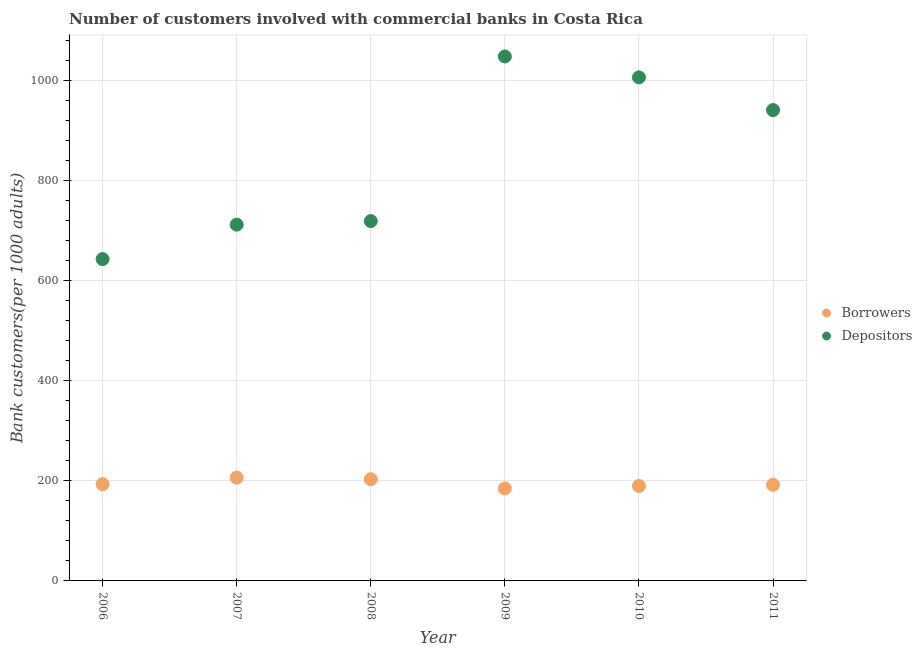How many different coloured dotlines are there?
Your response must be concise. 2. Is the number of dotlines equal to the number of legend labels?
Give a very brief answer. Yes. What is the number of borrowers in 2011?
Make the answer very short. 191.98. Across all years, what is the maximum number of depositors?
Make the answer very short. 1047.71. Across all years, what is the minimum number of depositors?
Your answer should be very brief. 642.93. What is the total number of borrowers in the graph?
Ensure brevity in your answer.  1169.06. What is the difference between the number of depositors in 2008 and that in 2011?
Ensure brevity in your answer.  -221.76. What is the difference between the number of depositors in 2011 and the number of borrowers in 2008?
Ensure brevity in your answer.  737.53. What is the average number of depositors per year?
Make the answer very short. 844.62. In the year 2007, what is the difference between the number of depositors and number of borrowers?
Make the answer very short. 505.35. What is the ratio of the number of depositors in 2006 to that in 2011?
Provide a succinct answer. 0.68. Is the number of depositors in 2007 less than that in 2009?
Keep it short and to the point. Yes. Is the difference between the number of borrowers in 2006 and 2011 greater than the difference between the number of depositors in 2006 and 2011?
Your response must be concise. Yes. What is the difference between the highest and the second highest number of borrowers?
Ensure brevity in your answer.  3.24. What is the difference between the highest and the lowest number of depositors?
Your response must be concise. 404.79. Is the sum of the number of depositors in 2006 and 2010 greater than the maximum number of borrowers across all years?
Your answer should be compact. Yes. Does the number of depositors monotonically increase over the years?
Provide a short and direct response. No. Is the number of depositors strictly greater than the number of borrowers over the years?
Give a very brief answer. Yes. How many years are there in the graph?
Your answer should be compact. 6. What is the difference between two consecutive major ticks on the Y-axis?
Make the answer very short. 200. Are the values on the major ticks of Y-axis written in scientific E-notation?
Offer a very short reply. No. Does the graph contain grids?
Your answer should be very brief. Yes. Where does the legend appear in the graph?
Your answer should be compact. Center right. How are the legend labels stacked?
Offer a terse response. Vertical. What is the title of the graph?
Offer a terse response. Number of customers involved with commercial banks in Costa Rica. What is the label or title of the X-axis?
Make the answer very short. Year. What is the label or title of the Y-axis?
Offer a terse response. Bank customers(per 1000 adults). What is the Bank customers(per 1000 adults) of Borrowers in 2006?
Your answer should be very brief. 193.3. What is the Bank customers(per 1000 adults) in Depositors in 2006?
Ensure brevity in your answer.  642.93. What is the Bank customers(per 1000 adults) in Borrowers in 2007?
Your answer should be compact. 206.33. What is the Bank customers(per 1000 adults) of Depositors in 2007?
Provide a succinct answer. 711.68. What is the Bank customers(per 1000 adults) in Borrowers in 2008?
Keep it short and to the point. 203.09. What is the Bank customers(per 1000 adults) of Depositors in 2008?
Your answer should be very brief. 718.87. What is the Bank customers(per 1000 adults) in Borrowers in 2009?
Your answer should be very brief. 184.73. What is the Bank customers(per 1000 adults) of Depositors in 2009?
Provide a short and direct response. 1047.71. What is the Bank customers(per 1000 adults) in Borrowers in 2010?
Your response must be concise. 189.63. What is the Bank customers(per 1000 adults) in Depositors in 2010?
Provide a succinct answer. 1005.94. What is the Bank customers(per 1000 adults) of Borrowers in 2011?
Ensure brevity in your answer.  191.98. What is the Bank customers(per 1000 adults) of Depositors in 2011?
Provide a short and direct response. 940.62. Across all years, what is the maximum Bank customers(per 1000 adults) of Borrowers?
Keep it short and to the point. 206.33. Across all years, what is the maximum Bank customers(per 1000 adults) in Depositors?
Provide a succinct answer. 1047.71. Across all years, what is the minimum Bank customers(per 1000 adults) in Borrowers?
Give a very brief answer. 184.73. Across all years, what is the minimum Bank customers(per 1000 adults) of Depositors?
Keep it short and to the point. 642.93. What is the total Bank customers(per 1000 adults) of Borrowers in the graph?
Provide a succinct answer. 1169.06. What is the total Bank customers(per 1000 adults) of Depositors in the graph?
Offer a terse response. 5067.75. What is the difference between the Bank customers(per 1000 adults) of Borrowers in 2006 and that in 2007?
Provide a succinct answer. -13.03. What is the difference between the Bank customers(per 1000 adults) of Depositors in 2006 and that in 2007?
Your response must be concise. -68.75. What is the difference between the Bank customers(per 1000 adults) in Borrowers in 2006 and that in 2008?
Provide a short and direct response. -9.79. What is the difference between the Bank customers(per 1000 adults) of Depositors in 2006 and that in 2008?
Provide a short and direct response. -75.94. What is the difference between the Bank customers(per 1000 adults) of Borrowers in 2006 and that in 2009?
Provide a short and direct response. 8.58. What is the difference between the Bank customers(per 1000 adults) in Depositors in 2006 and that in 2009?
Offer a very short reply. -404.79. What is the difference between the Bank customers(per 1000 adults) of Borrowers in 2006 and that in 2010?
Provide a succinct answer. 3.68. What is the difference between the Bank customers(per 1000 adults) in Depositors in 2006 and that in 2010?
Provide a succinct answer. -363.02. What is the difference between the Bank customers(per 1000 adults) in Borrowers in 2006 and that in 2011?
Your answer should be very brief. 1.32. What is the difference between the Bank customers(per 1000 adults) of Depositors in 2006 and that in 2011?
Ensure brevity in your answer.  -297.7. What is the difference between the Bank customers(per 1000 adults) of Borrowers in 2007 and that in 2008?
Your response must be concise. 3.24. What is the difference between the Bank customers(per 1000 adults) of Depositors in 2007 and that in 2008?
Keep it short and to the point. -7.19. What is the difference between the Bank customers(per 1000 adults) in Borrowers in 2007 and that in 2009?
Ensure brevity in your answer.  21.6. What is the difference between the Bank customers(per 1000 adults) of Depositors in 2007 and that in 2009?
Your response must be concise. -336.04. What is the difference between the Bank customers(per 1000 adults) in Borrowers in 2007 and that in 2010?
Provide a succinct answer. 16.7. What is the difference between the Bank customers(per 1000 adults) in Depositors in 2007 and that in 2010?
Give a very brief answer. -294.27. What is the difference between the Bank customers(per 1000 adults) of Borrowers in 2007 and that in 2011?
Provide a short and direct response. 14.35. What is the difference between the Bank customers(per 1000 adults) in Depositors in 2007 and that in 2011?
Keep it short and to the point. -228.95. What is the difference between the Bank customers(per 1000 adults) in Borrowers in 2008 and that in 2009?
Make the answer very short. 18.36. What is the difference between the Bank customers(per 1000 adults) in Depositors in 2008 and that in 2009?
Provide a succinct answer. -328.85. What is the difference between the Bank customers(per 1000 adults) of Borrowers in 2008 and that in 2010?
Your answer should be very brief. 13.46. What is the difference between the Bank customers(per 1000 adults) in Depositors in 2008 and that in 2010?
Offer a very short reply. -287.08. What is the difference between the Bank customers(per 1000 adults) of Borrowers in 2008 and that in 2011?
Provide a succinct answer. 11.11. What is the difference between the Bank customers(per 1000 adults) in Depositors in 2008 and that in 2011?
Offer a very short reply. -221.76. What is the difference between the Bank customers(per 1000 adults) of Borrowers in 2009 and that in 2010?
Provide a short and direct response. -4.9. What is the difference between the Bank customers(per 1000 adults) in Depositors in 2009 and that in 2010?
Make the answer very short. 41.77. What is the difference between the Bank customers(per 1000 adults) in Borrowers in 2009 and that in 2011?
Your answer should be compact. -7.25. What is the difference between the Bank customers(per 1000 adults) in Depositors in 2009 and that in 2011?
Provide a succinct answer. 107.09. What is the difference between the Bank customers(per 1000 adults) of Borrowers in 2010 and that in 2011?
Give a very brief answer. -2.35. What is the difference between the Bank customers(per 1000 adults) in Depositors in 2010 and that in 2011?
Your answer should be very brief. 65.32. What is the difference between the Bank customers(per 1000 adults) in Borrowers in 2006 and the Bank customers(per 1000 adults) in Depositors in 2007?
Ensure brevity in your answer.  -518.37. What is the difference between the Bank customers(per 1000 adults) in Borrowers in 2006 and the Bank customers(per 1000 adults) in Depositors in 2008?
Give a very brief answer. -525.56. What is the difference between the Bank customers(per 1000 adults) of Borrowers in 2006 and the Bank customers(per 1000 adults) of Depositors in 2009?
Ensure brevity in your answer.  -854.41. What is the difference between the Bank customers(per 1000 adults) in Borrowers in 2006 and the Bank customers(per 1000 adults) in Depositors in 2010?
Offer a very short reply. -812.64. What is the difference between the Bank customers(per 1000 adults) of Borrowers in 2006 and the Bank customers(per 1000 adults) of Depositors in 2011?
Offer a terse response. -747.32. What is the difference between the Bank customers(per 1000 adults) of Borrowers in 2007 and the Bank customers(per 1000 adults) of Depositors in 2008?
Keep it short and to the point. -512.54. What is the difference between the Bank customers(per 1000 adults) of Borrowers in 2007 and the Bank customers(per 1000 adults) of Depositors in 2009?
Your response must be concise. -841.38. What is the difference between the Bank customers(per 1000 adults) in Borrowers in 2007 and the Bank customers(per 1000 adults) in Depositors in 2010?
Provide a succinct answer. -799.61. What is the difference between the Bank customers(per 1000 adults) in Borrowers in 2007 and the Bank customers(per 1000 adults) in Depositors in 2011?
Offer a terse response. -734.29. What is the difference between the Bank customers(per 1000 adults) of Borrowers in 2008 and the Bank customers(per 1000 adults) of Depositors in 2009?
Give a very brief answer. -844.62. What is the difference between the Bank customers(per 1000 adults) in Borrowers in 2008 and the Bank customers(per 1000 adults) in Depositors in 2010?
Provide a short and direct response. -802.85. What is the difference between the Bank customers(per 1000 adults) of Borrowers in 2008 and the Bank customers(per 1000 adults) of Depositors in 2011?
Your answer should be very brief. -737.53. What is the difference between the Bank customers(per 1000 adults) of Borrowers in 2009 and the Bank customers(per 1000 adults) of Depositors in 2010?
Offer a terse response. -821.21. What is the difference between the Bank customers(per 1000 adults) of Borrowers in 2009 and the Bank customers(per 1000 adults) of Depositors in 2011?
Provide a succinct answer. -755.89. What is the difference between the Bank customers(per 1000 adults) in Borrowers in 2010 and the Bank customers(per 1000 adults) in Depositors in 2011?
Your answer should be compact. -750.99. What is the average Bank customers(per 1000 adults) in Borrowers per year?
Your response must be concise. 194.84. What is the average Bank customers(per 1000 adults) of Depositors per year?
Offer a very short reply. 844.62. In the year 2006, what is the difference between the Bank customers(per 1000 adults) of Borrowers and Bank customers(per 1000 adults) of Depositors?
Your answer should be very brief. -449.62. In the year 2007, what is the difference between the Bank customers(per 1000 adults) in Borrowers and Bank customers(per 1000 adults) in Depositors?
Give a very brief answer. -505.35. In the year 2008, what is the difference between the Bank customers(per 1000 adults) in Borrowers and Bank customers(per 1000 adults) in Depositors?
Keep it short and to the point. -515.78. In the year 2009, what is the difference between the Bank customers(per 1000 adults) of Borrowers and Bank customers(per 1000 adults) of Depositors?
Your answer should be compact. -862.99. In the year 2010, what is the difference between the Bank customers(per 1000 adults) of Borrowers and Bank customers(per 1000 adults) of Depositors?
Offer a very short reply. -816.31. In the year 2011, what is the difference between the Bank customers(per 1000 adults) in Borrowers and Bank customers(per 1000 adults) in Depositors?
Provide a short and direct response. -748.64. What is the ratio of the Bank customers(per 1000 adults) of Borrowers in 2006 to that in 2007?
Provide a short and direct response. 0.94. What is the ratio of the Bank customers(per 1000 adults) in Depositors in 2006 to that in 2007?
Your answer should be very brief. 0.9. What is the ratio of the Bank customers(per 1000 adults) of Borrowers in 2006 to that in 2008?
Your answer should be compact. 0.95. What is the ratio of the Bank customers(per 1000 adults) in Depositors in 2006 to that in 2008?
Make the answer very short. 0.89. What is the ratio of the Bank customers(per 1000 adults) in Borrowers in 2006 to that in 2009?
Provide a short and direct response. 1.05. What is the ratio of the Bank customers(per 1000 adults) in Depositors in 2006 to that in 2009?
Make the answer very short. 0.61. What is the ratio of the Bank customers(per 1000 adults) of Borrowers in 2006 to that in 2010?
Offer a terse response. 1.02. What is the ratio of the Bank customers(per 1000 adults) in Depositors in 2006 to that in 2010?
Your answer should be very brief. 0.64. What is the ratio of the Bank customers(per 1000 adults) of Borrowers in 2006 to that in 2011?
Your answer should be very brief. 1.01. What is the ratio of the Bank customers(per 1000 adults) of Depositors in 2006 to that in 2011?
Offer a very short reply. 0.68. What is the ratio of the Bank customers(per 1000 adults) of Borrowers in 2007 to that in 2008?
Give a very brief answer. 1.02. What is the ratio of the Bank customers(per 1000 adults) of Borrowers in 2007 to that in 2009?
Provide a succinct answer. 1.12. What is the ratio of the Bank customers(per 1000 adults) of Depositors in 2007 to that in 2009?
Your response must be concise. 0.68. What is the ratio of the Bank customers(per 1000 adults) of Borrowers in 2007 to that in 2010?
Offer a very short reply. 1.09. What is the ratio of the Bank customers(per 1000 adults) of Depositors in 2007 to that in 2010?
Your response must be concise. 0.71. What is the ratio of the Bank customers(per 1000 adults) in Borrowers in 2007 to that in 2011?
Give a very brief answer. 1.07. What is the ratio of the Bank customers(per 1000 adults) of Depositors in 2007 to that in 2011?
Your response must be concise. 0.76. What is the ratio of the Bank customers(per 1000 adults) of Borrowers in 2008 to that in 2009?
Make the answer very short. 1.1. What is the ratio of the Bank customers(per 1000 adults) of Depositors in 2008 to that in 2009?
Provide a succinct answer. 0.69. What is the ratio of the Bank customers(per 1000 adults) in Borrowers in 2008 to that in 2010?
Provide a short and direct response. 1.07. What is the ratio of the Bank customers(per 1000 adults) of Depositors in 2008 to that in 2010?
Provide a succinct answer. 0.71. What is the ratio of the Bank customers(per 1000 adults) of Borrowers in 2008 to that in 2011?
Your answer should be very brief. 1.06. What is the ratio of the Bank customers(per 1000 adults) in Depositors in 2008 to that in 2011?
Your response must be concise. 0.76. What is the ratio of the Bank customers(per 1000 adults) in Borrowers in 2009 to that in 2010?
Offer a terse response. 0.97. What is the ratio of the Bank customers(per 1000 adults) of Depositors in 2009 to that in 2010?
Make the answer very short. 1.04. What is the ratio of the Bank customers(per 1000 adults) of Borrowers in 2009 to that in 2011?
Offer a terse response. 0.96. What is the ratio of the Bank customers(per 1000 adults) of Depositors in 2009 to that in 2011?
Give a very brief answer. 1.11. What is the ratio of the Bank customers(per 1000 adults) in Borrowers in 2010 to that in 2011?
Keep it short and to the point. 0.99. What is the ratio of the Bank customers(per 1000 adults) of Depositors in 2010 to that in 2011?
Your answer should be compact. 1.07. What is the difference between the highest and the second highest Bank customers(per 1000 adults) of Borrowers?
Your response must be concise. 3.24. What is the difference between the highest and the second highest Bank customers(per 1000 adults) in Depositors?
Provide a succinct answer. 41.77. What is the difference between the highest and the lowest Bank customers(per 1000 adults) in Borrowers?
Offer a terse response. 21.6. What is the difference between the highest and the lowest Bank customers(per 1000 adults) in Depositors?
Your answer should be compact. 404.79. 